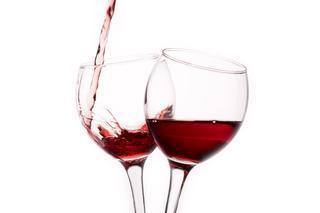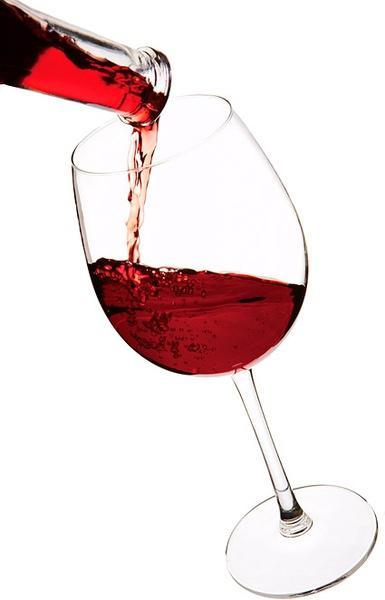The first image is the image on the left, the second image is the image on the right. Assess this claim about the two images: "There is at least two wine glasses in the left image.". Correct or not? Answer yes or no. Yes. The first image is the image on the left, the second image is the image on the right. Examine the images to the left and right. Is the description "The left image shows two glasses of red wine while the right image shows one" accurate? Answer yes or no. Yes. 